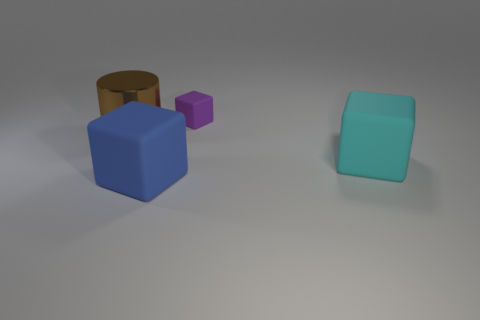There is a object that is on the right side of the large blue thing and in front of the purple block; what is it made of?
Ensure brevity in your answer.  Rubber. Is the material of the big block to the right of the tiny purple thing the same as the big block to the left of the tiny purple rubber cube?
Ensure brevity in your answer.  Yes. The cyan matte block is what size?
Provide a succinct answer. Large. There is a blue object that is the same shape as the large cyan rubber thing; what is its size?
Keep it short and to the point. Large. How many objects are in front of the big brown metal thing?
Offer a very short reply. 2. What color is the cube to the left of the rubber object behind the brown shiny object?
Offer a terse response. Blue. Are there any other things that have the same shape as the large brown metal thing?
Provide a short and direct response. No. Are there an equal number of big cyan matte objects to the left of the tiny purple rubber thing and blue things behind the blue matte cube?
Your answer should be compact. Yes. What number of spheres are either shiny things or large blue objects?
Provide a short and direct response. 0. What number of other things are the same material as the big blue block?
Keep it short and to the point. 2. 